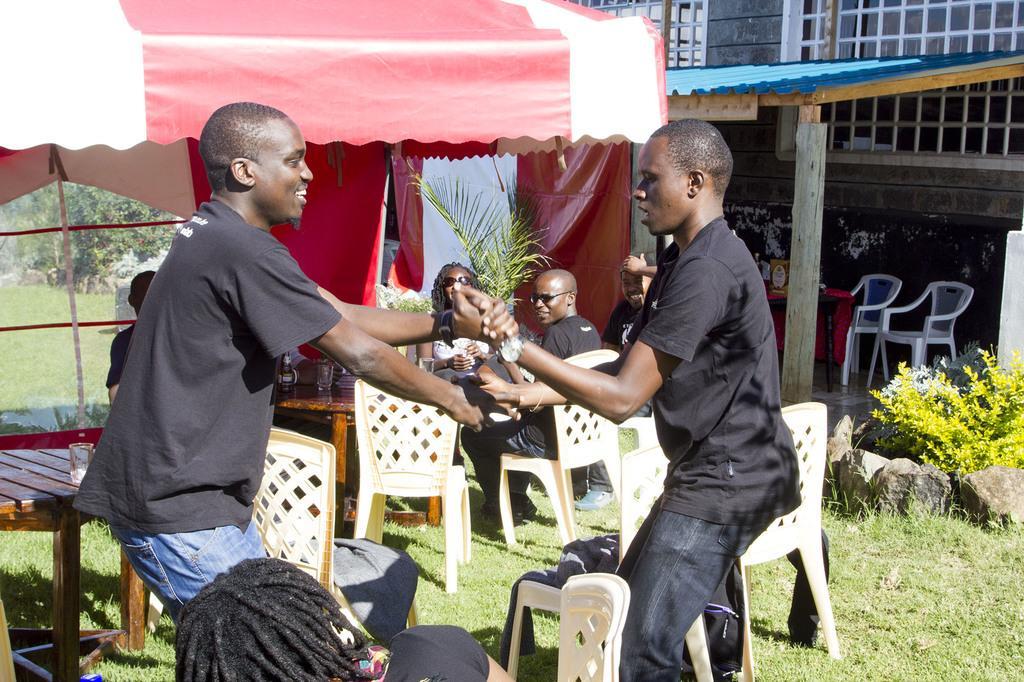Can you describe this image briefly? An outdoor picture. Front this two men are holding their hands and wore black t-shirts. Under this tent few persons are sitting on chairs. In-front of them there are table, on this table there is a glass. We can able to see grass, plants, stones and trees. This is building with shed. 